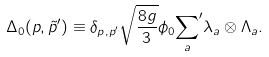<formula> <loc_0><loc_0><loc_500><loc_500>\Delta _ { 0 } ( p , \tilde { p } ^ { \prime } ) \equiv \delta _ { p , p ^ { \prime } } \sqrt { \frac { 8 g } { 3 } } \phi _ { 0 } { \sum _ { a } } ^ { \prime } \lambda _ { a } \otimes \Lambda _ { a } .</formula> 